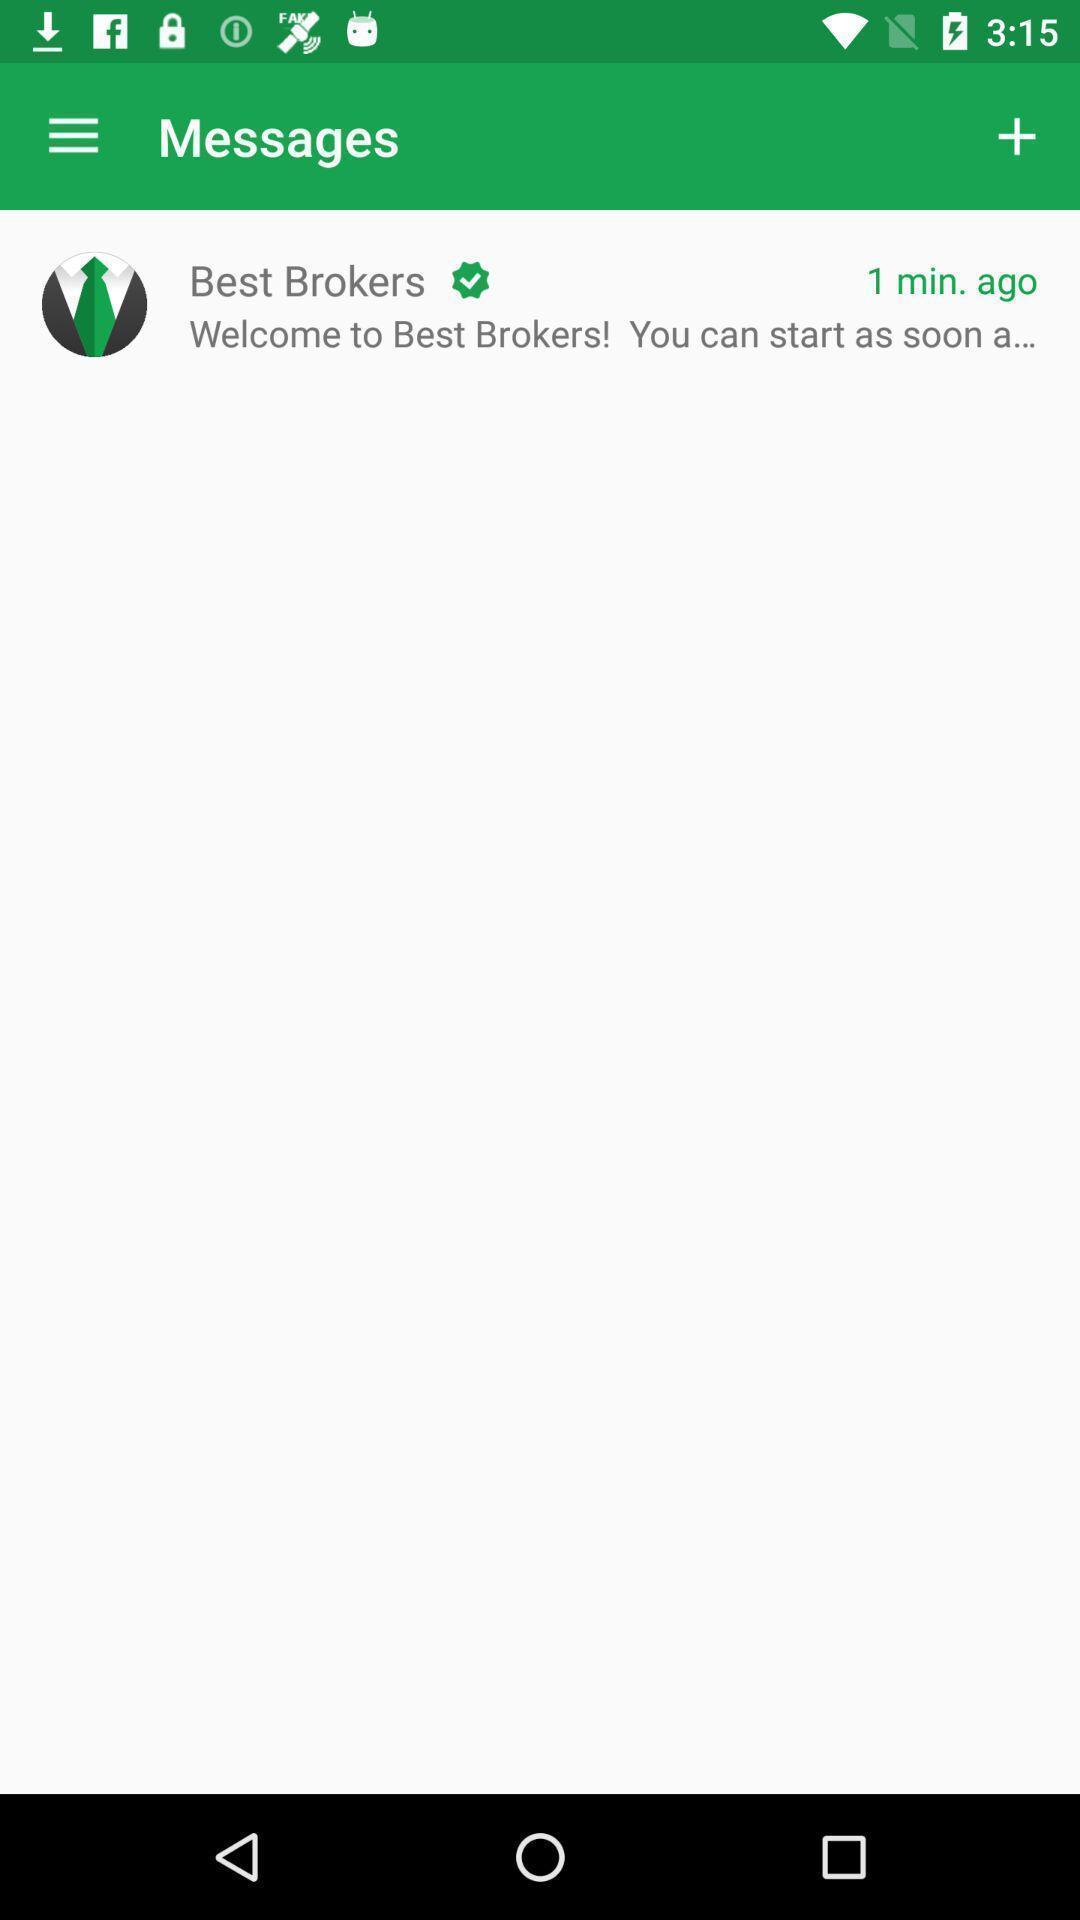Tell me about the visual elements in this screen capture. Screen shows a welcome message for fun gaming app. 